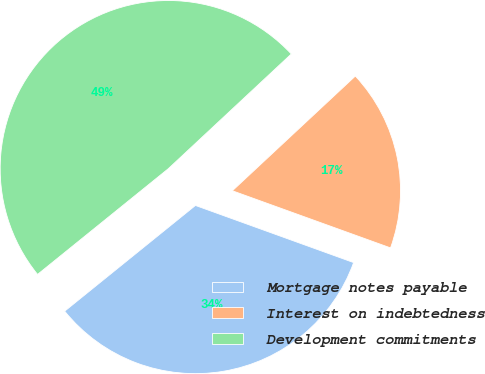<chart> <loc_0><loc_0><loc_500><loc_500><pie_chart><fcel>Mortgage notes payable<fcel>Interest on indebtedness<fcel>Development commitments<nl><fcel>33.66%<fcel>17.46%<fcel>48.87%<nl></chart> 